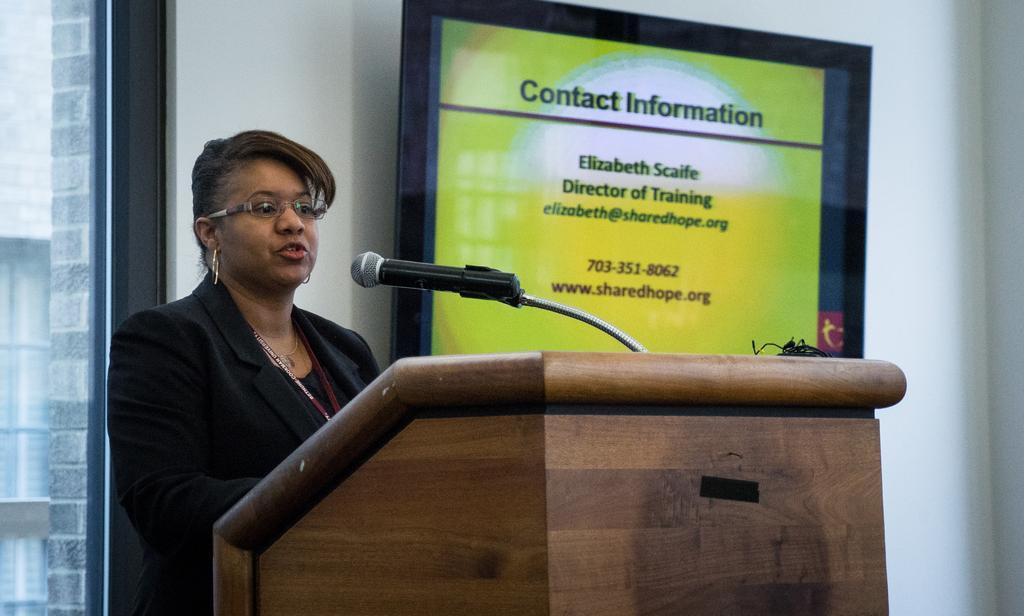Could you give a brief overview of what you see in this image? In this image there is a woman standing near the podium and in front of the mic. In the background there is a wall to which there is a board. On the left side there is a glass window in the background. 